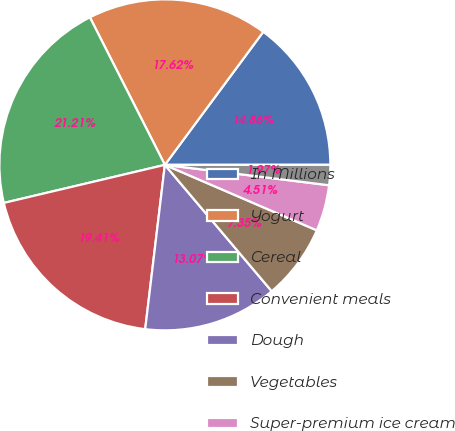Convert chart. <chart><loc_0><loc_0><loc_500><loc_500><pie_chart><fcel>In Millions<fcel>Yogurt<fcel>Cereal<fcel>Convenient meals<fcel>Dough<fcel>Vegetables<fcel>Super-premium ice cream<fcel>Other<nl><fcel>14.86%<fcel>17.62%<fcel>21.21%<fcel>19.41%<fcel>13.07%<fcel>7.35%<fcel>4.51%<fcel>1.97%<nl></chart> 